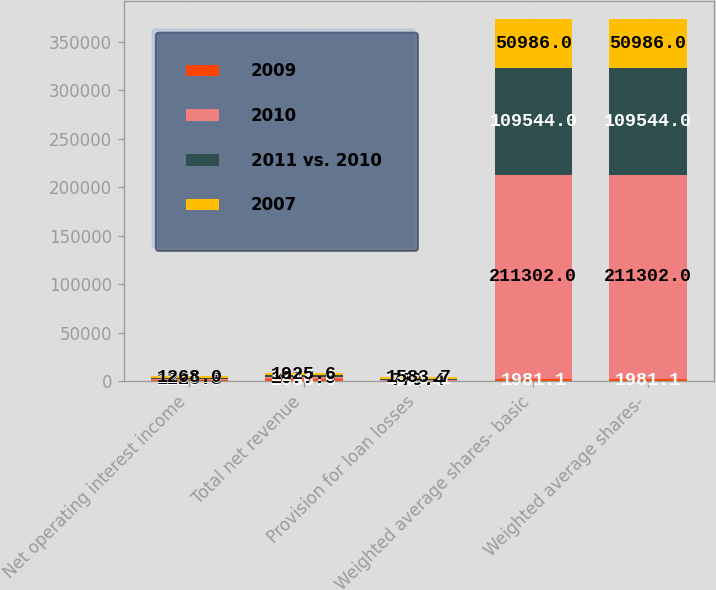<chart> <loc_0><loc_0><loc_500><loc_500><stacked_bar_chart><ecel><fcel>Net operating interest income<fcel>Total net revenue<fcel>Provision for loan losses<fcel>Weighted average shares- basic<fcel>Weighted average shares-<nl><fcel>2009<fcel>1220<fcel>2036.6<fcel>440.6<fcel>1981.1<fcel>1981.1<nl><fcel>2010<fcel>1226.3<fcel>2077.9<fcel>779.4<fcel>211302<fcel>211302<nl><fcel>2011 vs. 2010<fcel>1260.6<fcel>2217<fcel>1498.1<fcel>109544<fcel>109544<nl><fcel>2007<fcel>1268<fcel>1925.6<fcel>1583.7<fcel>50986<fcel>50986<nl></chart> 